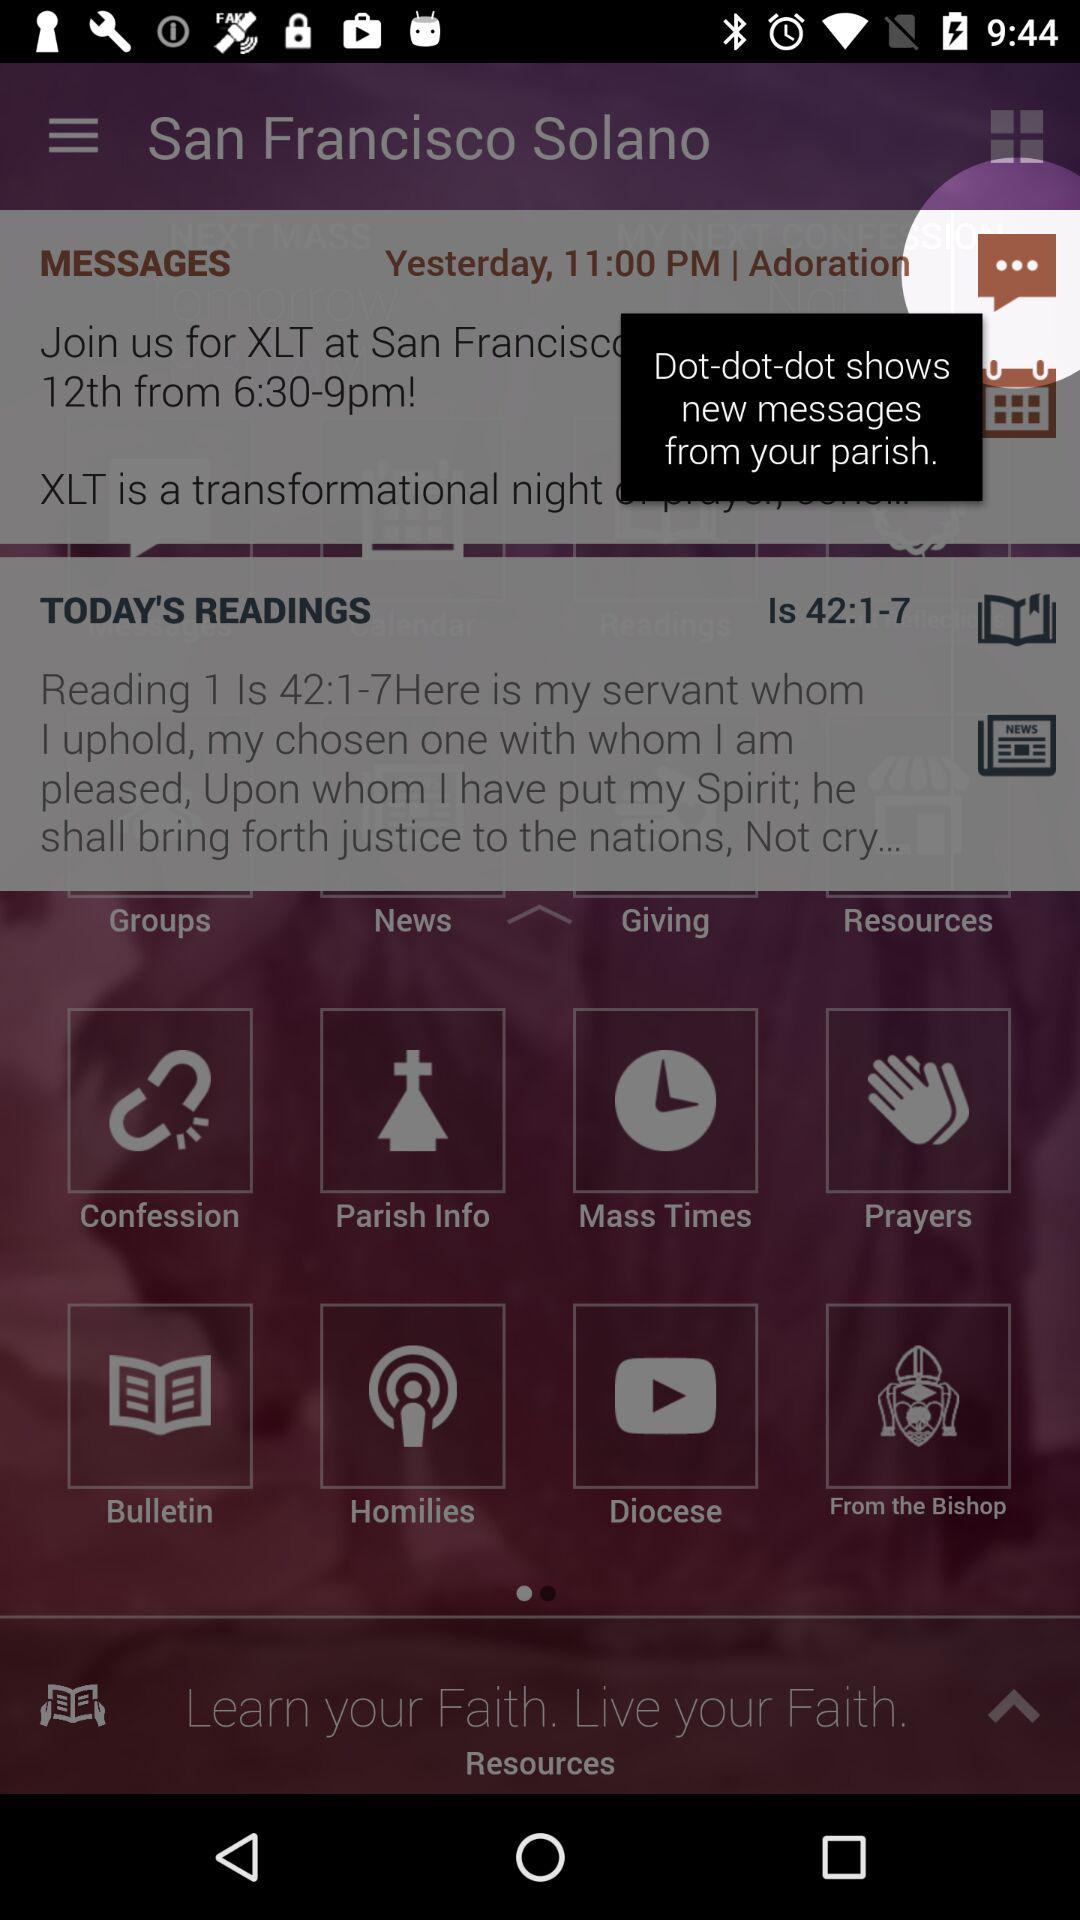At what time message was received yesterday? The message was received at 11 p.m. yesterday. 